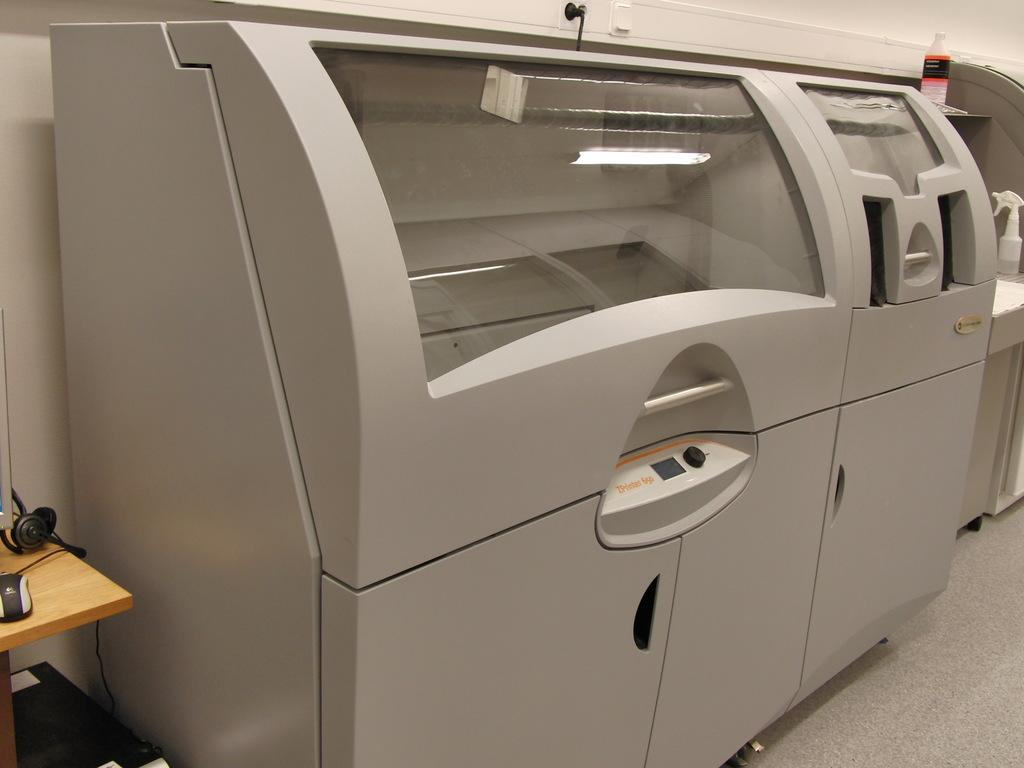What is the main subject in the image? There is a machine in the image. Can you describe the objects on the table on the left side of the image? Unfortunately, the provided facts do not mention any objects on a table on the left side of the image. How many men are coughing in the image? There are no men or coughing depicted in the image. What riddle is being solved in the image? There is no riddle being solved in the image. 